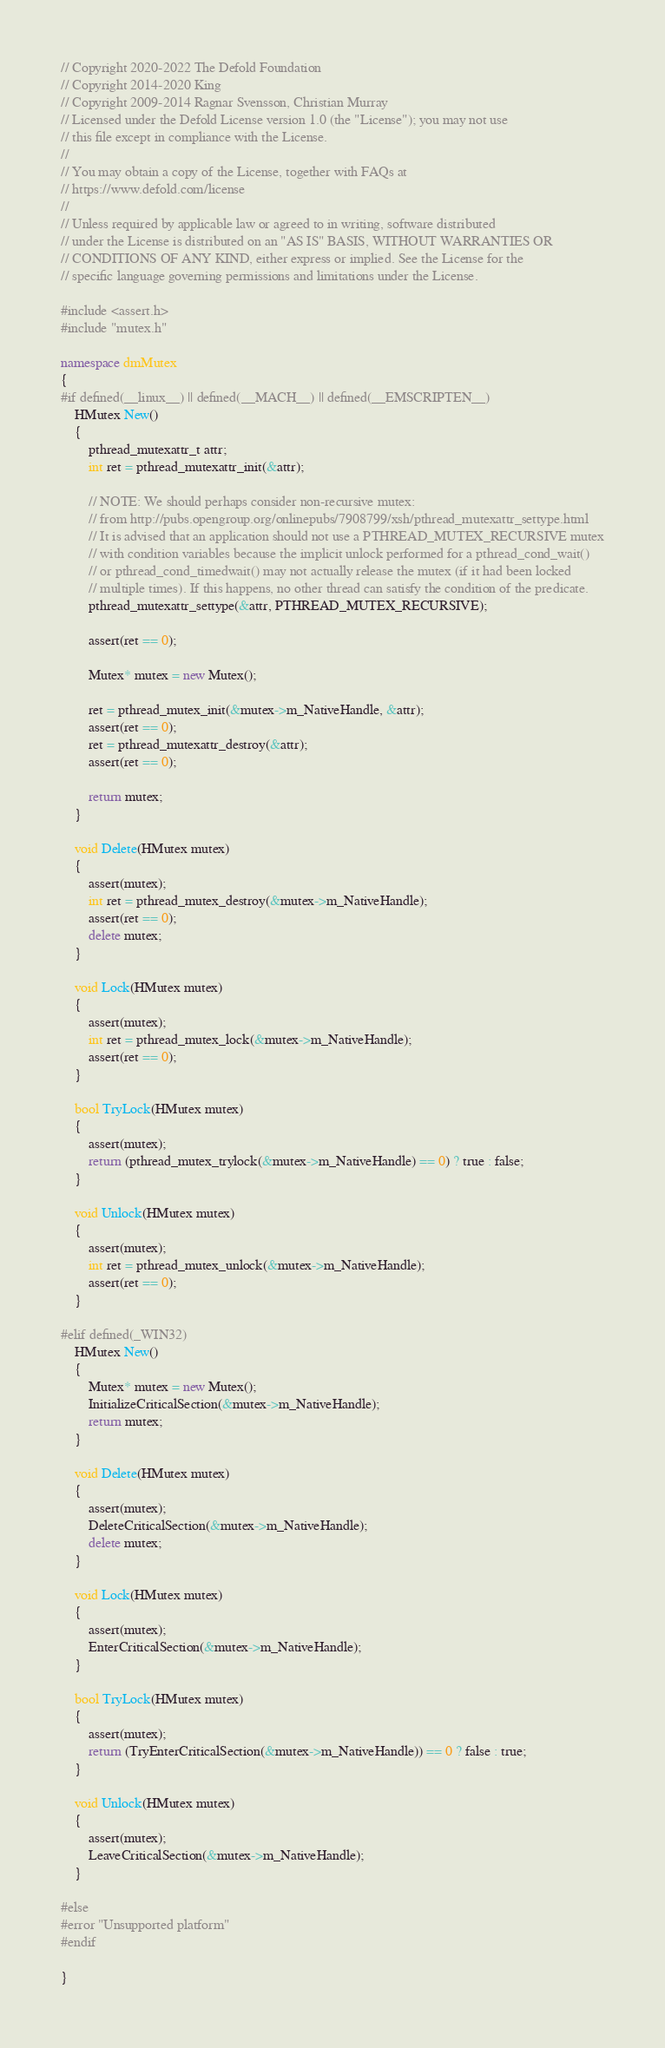<code> <loc_0><loc_0><loc_500><loc_500><_C++_>// Copyright 2020-2022 The Defold Foundation
// Copyright 2014-2020 King
// Copyright 2009-2014 Ragnar Svensson, Christian Murray
// Licensed under the Defold License version 1.0 (the "License"); you may not use
// this file except in compliance with the License.
// 
// You may obtain a copy of the License, together with FAQs at
// https://www.defold.com/license
// 
// Unless required by applicable law or agreed to in writing, software distributed
// under the License is distributed on an "AS IS" BASIS, WITHOUT WARRANTIES OR
// CONDITIONS OF ANY KIND, either express or implied. See the License for the
// specific language governing permissions and limitations under the License.

#include <assert.h>
#include "mutex.h"

namespace dmMutex
{
#if defined(__linux__) || defined(__MACH__) || defined(__EMSCRIPTEN__)
    HMutex New()
    {
        pthread_mutexattr_t attr;
        int ret = pthread_mutexattr_init(&attr);

        // NOTE: We should perhaps consider non-recursive mutex:
        // from http://pubs.opengroup.org/onlinepubs/7908799/xsh/pthread_mutexattr_settype.html
        // It is advised that an application should not use a PTHREAD_MUTEX_RECURSIVE mutex
        // with condition variables because the implicit unlock performed for a pthread_cond_wait()
        // or pthread_cond_timedwait() may not actually release the mutex (if it had been locked
        // multiple times). If this happens, no other thread can satisfy the condition of the predicate.
        pthread_mutexattr_settype(&attr, PTHREAD_MUTEX_RECURSIVE);

        assert(ret == 0);

        Mutex* mutex = new Mutex();

        ret = pthread_mutex_init(&mutex->m_NativeHandle, &attr);
        assert(ret == 0);
        ret = pthread_mutexattr_destroy(&attr);
        assert(ret == 0);

        return mutex;
    }

    void Delete(HMutex mutex)
    {
        assert(mutex);
        int ret = pthread_mutex_destroy(&mutex->m_NativeHandle);
        assert(ret == 0);
        delete mutex;
    }

    void Lock(HMutex mutex)
    {
        assert(mutex);
        int ret = pthread_mutex_lock(&mutex->m_NativeHandle);
        assert(ret == 0);
    }

    bool TryLock(HMutex mutex)
    {
        assert(mutex);
        return (pthread_mutex_trylock(&mutex->m_NativeHandle) == 0) ? true : false;
    }

    void Unlock(HMutex mutex)
    {
        assert(mutex);
        int ret = pthread_mutex_unlock(&mutex->m_NativeHandle);
        assert(ret == 0);
    }

#elif defined(_WIN32)
    HMutex New()
    {
        Mutex* mutex = new Mutex();
        InitializeCriticalSection(&mutex->m_NativeHandle);
        return mutex;
    }

    void Delete(HMutex mutex)
    {
        assert(mutex);
        DeleteCriticalSection(&mutex->m_NativeHandle);
        delete mutex;
    }

    void Lock(HMutex mutex)
    {
        assert(mutex);
        EnterCriticalSection(&mutex->m_NativeHandle);
    }

    bool TryLock(HMutex mutex)
    {
        assert(mutex);
        return (TryEnterCriticalSection(&mutex->m_NativeHandle)) == 0 ? false : true;
    }

    void Unlock(HMutex mutex)
    {
        assert(mutex);
        LeaveCriticalSection(&mutex->m_NativeHandle);
    }

#else
#error "Unsupported platform"
#endif

}

</code> 